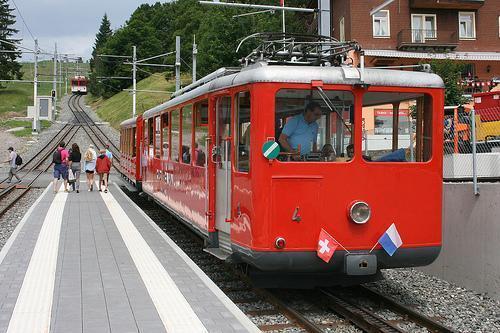How many people are driving the trolley?
Give a very brief answer. 1. 